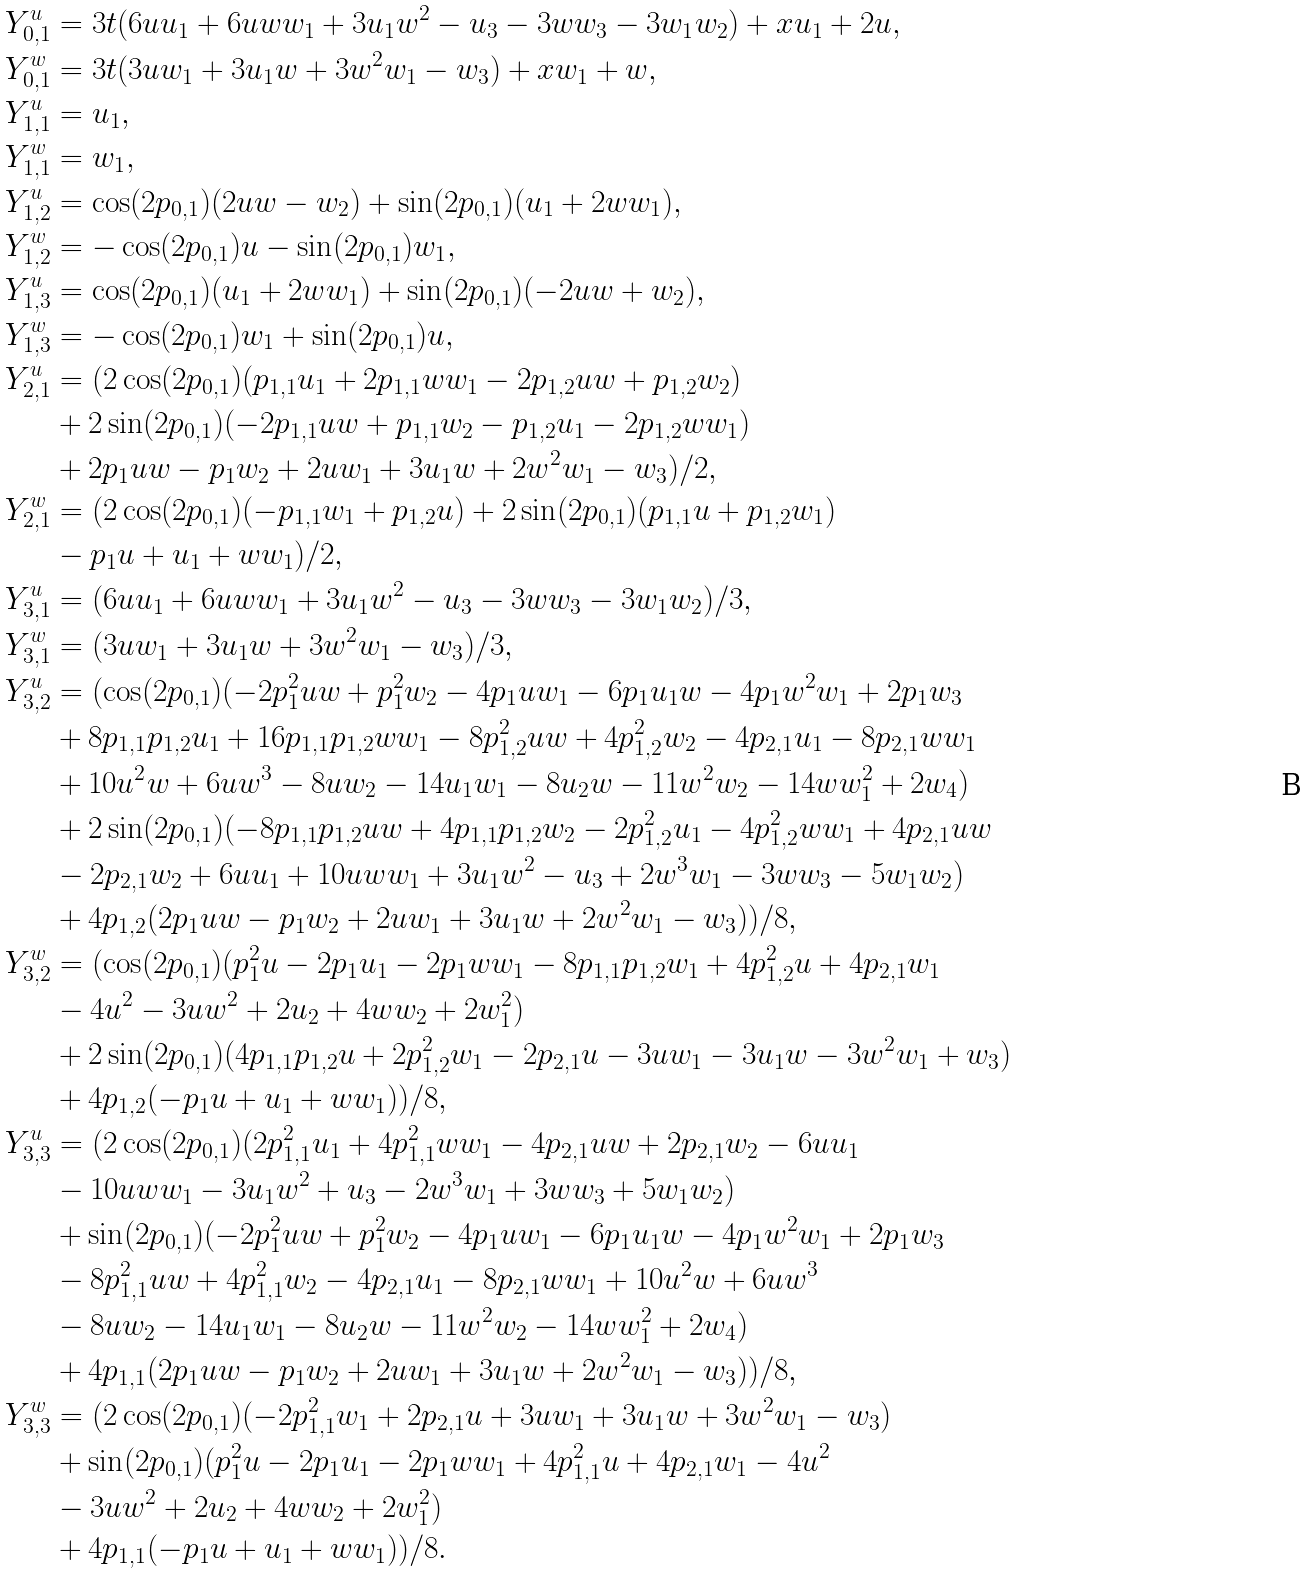Convert formula to latex. <formula><loc_0><loc_0><loc_500><loc_500>Y _ { 0 , 1 } ^ { u } & = 3 t ( 6 u u _ { 1 } + 6 u w w _ { 1 } + 3 u _ { 1 } w ^ { 2 } - u _ { 3 } - 3 w w _ { 3 } - 3 w _ { 1 } w _ { 2 } ) + x u _ { 1 } + 2 u , \\ Y _ { 0 , 1 } ^ { w } & = 3 t ( 3 u w _ { 1 } + 3 u _ { 1 } w + 3 w ^ { 2 } w _ { 1 } - w _ { 3 } ) + x w _ { 1 } + w , \\ Y _ { 1 , 1 } ^ { u } & = u _ { 1 } , \\ Y _ { 1 , 1 } ^ { w } & = w _ { 1 } , \\ Y _ { 1 , 2 } ^ { u } & = \cos ( 2 p _ { 0 , 1 } ) ( 2 u w - w _ { 2 } ) + \sin ( 2 p _ { 0 , 1 } ) ( u _ { 1 } + 2 w w _ { 1 } ) , \\ Y _ { 1 , 2 } ^ { w } & = - \cos ( 2 p _ { 0 , 1 } ) u - \sin ( 2 p _ { 0 , 1 } ) w _ { 1 } , \\ Y _ { 1 , 3 } ^ { u } & = \cos ( 2 p _ { 0 , 1 } ) ( u _ { 1 } + 2 w w _ { 1 } ) + \sin ( 2 p _ { 0 , 1 } ) ( - 2 u w + w _ { 2 } ) , \\ Y _ { 1 , 3 } ^ { w } & = - \cos ( 2 p _ { 0 , 1 } ) w _ { 1 } + \sin ( 2 p _ { 0 , 1 } ) u , \\ Y _ { 2 , 1 } ^ { u } & = ( 2 \cos ( 2 p _ { 0 , 1 } ) ( p _ { 1 , 1 } u _ { 1 } + 2 p _ { 1 , 1 } w w _ { 1 } - 2 p _ { 1 , 2 } u w + p _ { 1 , 2 } w _ { 2 } ) \\ & + 2 \sin ( 2 p _ { 0 , 1 } ) ( - 2 p _ { 1 , 1 } u w + p _ { 1 , 1 } w _ { 2 } - p _ { 1 , 2 } u _ { 1 } - 2 p _ { 1 , 2 } w w _ { 1 } ) \\ & + 2 p _ { 1 } u w - p _ { 1 } w _ { 2 } + 2 u w _ { 1 } + 3 u _ { 1 } w + 2 w ^ { 2 } w _ { 1 } - w _ { 3 } ) / 2 , \\ Y _ { 2 , 1 } ^ { w } & = ( 2 \cos ( 2 p _ { 0 , 1 } ) ( - p _ { 1 , 1 } w _ { 1 } + p _ { 1 , 2 } u ) + 2 \sin ( 2 p _ { 0 , 1 } ) ( p _ { 1 , 1 } u + p _ { 1 , 2 } w _ { 1 } ) \\ & - p _ { 1 } u + u _ { 1 } + w w _ { 1 } ) / 2 , \\ Y _ { 3 , 1 } ^ { u } & = ( 6 u u _ { 1 } + 6 u w w _ { 1 } + 3 u _ { 1 } w ^ { 2 } - u _ { 3 } - 3 w w _ { 3 } - 3 w _ { 1 } w _ { 2 } ) / 3 , \\ Y _ { 3 , 1 } ^ { w } & = ( 3 u w _ { 1 } + 3 u _ { 1 } w + 3 w ^ { 2 } w _ { 1 } - w _ { 3 } ) / 3 , \\ Y _ { 3 , 2 } ^ { u } & = ( \cos ( 2 p _ { 0 , 1 } ) ( - 2 p _ { 1 } ^ { 2 } u w + p _ { 1 } ^ { 2 } w _ { 2 } - 4 p _ { 1 } u w _ { 1 } - 6 p _ { 1 } u _ { 1 } w - 4 p _ { 1 } w ^ { 2 } w _ { 1 } + 2 p _ { 1 } w _ { 3 } \\ & + 8 p _ { 1 , 1 } p _ { 1 , 2 } u _ { 1 } + 1 6 p _ { 1 , 1 } p _ { 1 , 2 } w w _ { 1 } - 8 p _ { 1 , 2 } ^ { 2 } u w + 4 p _ { 1 , 2 } ^ { 2 } w _ { 2 } - 4 p _ { 2 , 1 } u _ { 1 } - 8 p _ { 2 , 1 } w w _ { 1 } \\ & + 1 0 u ^ { 2 } w + 6 u w ^ { 3 } - 8 u w _ { 2 } - 1 4 u _ { 1 } w _ { 1 } - 8 u _ { 2 } w - 1 1 w ^ { 2 } w _ { 2 } - 1 4 w w _ { 1 } ^ { 2 } + 2 w _ { 4 } ) \\ & + 2 \sin ( 2 p _ { 0 , 1 } ) ( - 8 p _ { 1 , 1 } p _ { 1 , 2 } u w + 4 p _ { 1 , 1 } p _ { 1 , 2 } w _ { 2 } - 2 p _ { 1 , 2 } ^ { 2 } u _ { 1 } - 4 p _ { 1 , 2 } ^ { 2 } w w _ { 1 } + 4 p _ { 2 , 1 } u w \\ & - 2 p _ { 2 , 1 } w _ { 2 } + 6 u u _ { 1 } + 1 0 u w w _ { 1 } + 3 u _ { 1 } w ^ { 2 } - u _ { 3 } + 2 w ^ { 3 } w _ { 1 } - 3 w w _ { 3 } - 5 w _ { 1 } w _ { 2 } ) \\ & + 4 p _ { 1 , 2 } ( 2 p _ { 1 } u w - p _ { 1 } w _ { 2 } + 2 u w _ { 1 } + 3 u _ { 1 } w + 2 w ^ { 2 } w _ { 1 } - w _ { 3 } ) ) / 8 , \\ Y _ { 3 , 2 } ^ { w } & = ( \cos ( 2 p _ { 0 , 1 } ) ( p _ { 1 } ^ { 2 } u - 2 p _ { 1 } u _ { 1 } - 2 p _ { 1 } w w _ { 1 } - 8 p _ { 1 , 1 } p _ { 1 , 2 } w _ { 1 } + 4 p _ { 1 , 2 } ^ { 2 } u + 4 p _ { 2 , 1 } w _ { 1 } \\ & - 4 u ^ { 2 } - 3 u w ^ { 2 } + 2 u _ { 2 } + 4 w w _ { 2 } + 2 w _ { 1 } ^ { 2 } ) \\ & + 2 \sin ( 2 p _ { 0 , 1 } ) ( 4 p _ { 1 , 1 } p _ { 1 , 2 } u + 2 p _ { 1 , 2 } ^ { 2 } w _ { 1 } - 2 p _ { 2 , 1 } u - 3 u w _ { 1 } - 3 u _ { 1 } w - 3 w ^ { 2 } w _ { 1 } + w _ { 3 } ) \\ & + 4 p _ { 1 , 2 } ( - p _ { 1 } u + u _ { 1 } + w w _ { 1 } ) ) / 8 , \\ Y _ { 3 , 3 } ^ { u } & = ( 2 \cos ( 2 p _ { 0 , 1 } ) ( 2 p _ { 1 , 1 } ^ { 2 } u _ { 1 } + 4 p _ { 1 , 1 } ^ { 2 } w w _ { 1 } - 4 p _ { 2 , 1 } u w + 2 p _ { 2 , 1 } w _ { 2 } - 6 u u _ { 1 } \\ & - 1 0 u w w _ { 1 } - 3 u _ { 1 } w ^ { 2 } + u _ { 3 } - 2 w ^ { 3 } w _ { 1 } + 3 w w _ { 3 } + 5 w _ { 1 } w _ { 2 } ) \\ & + \sin ( 2 p _ { 0 , 1 } ) ( - 2 p _ { 1 } ^ { 2 } u w + p _ { 1 } ^ { 2 } w _ { 2 } - 4 p _ { 1 } u w _ { 1 } - 6 p _ { 1 } u _ { 1 } w - 4 p _ { 1 } w ^ { 2 } w _ { 1 } + 2 p _ { 1 } w _ { 3 } \\ & - 8 p _ { 1 , 1 } ^ { 2 } u w + 4 p _ { 1 , 1 } ^ { 2 } w _ { 2 } - 4 p _ { 2 , 1 } u _ { 1 } - 8 p _ { 2 , 1 } w w _ { 1 } + 1 0 u ^ { 2 } w + 6 u w ^ { 3 } \\ & - 8 u w _ { 2 } - 1 4 u _ { 1 } w _ { 1 } - 8 u _ { 2 } w - 1 1 w ^ { 2 } w _ { 2 } - 1 4 w w _ { 1 } ^ { 2 } + 2 w _ { 4 } ) \\ & + 4 p _ { 1 , 1 } ( 2 p _ { 1 } u w - p _ { 1 } w _ { 2 } + 2 u w _ { 1 } + 3 u _ { 1 } w + 2 w ^ { 2 } w _ { 1 } - w _ { 3 } ) ) / 8 , \\ Y _ { 3 , 3 } ^ { w } & = ( 2 \cos ( 2 p _ { 0 , 1 } ) ( - 2 p _ { 1 , 1 } ^ { 2 } w _ { 1 } + 2 p _ { 2 , 1 } u + 3 u w _ { 1 } + 3 u _ { 1 } w + 3 w ^ { 2 } w _ { 1 } - w _ { 3 } ) \\ & + \sin ( 2 p _ { 0 , 1 } ) ( p _ { 1 } ^ { 2 } u - 2 p _ { 1 } u _ { 1 } - 2 p _ { 1 } w w _ { 1 } + 4 p _ { 1 , 1 } ^ { 2 } u + 4 p _ { 2 , 1 } w _ { 1 } - 4 u ^ { 2 } \\ & - 3 u w ^ { 2 } + 2 u _ { 2 } + 4 w w _ { 2 } + 2 w _ { 1 } ^ { 2 } ) \\ & + 4 p _ { 1 , 1 } ( - p _ { 1 } u + u _ { 1 } + w w _ { 1 } ) ) / 8 .</formula> 